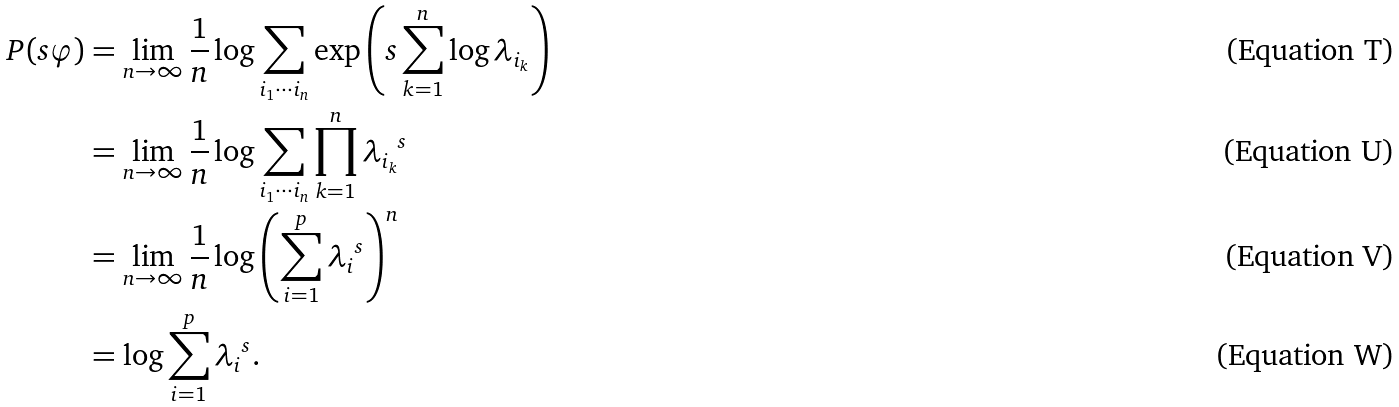<formula> <loc_0><loc_0><loc_500><loc_500>P ( s \varphi ) & = \lim _ { n \to \infty } \frac { 1 } { n } \log \sum _ { i _ { 1 } \cdots i _ { n } } \exp \left ( s \sum _ { k = 1 } ^ { n } \log \lambda _ { i _ { k } } \right ) \\ & = \lim _ { n \to \infty } \frac { 1 } { n } \log \sum _ { i _ { 1 } \cdots i _ { n } } \prod _ { k = 1 } ^ { n } { \lambda _ { i _ { k } } } ^ { s } \\ & = \lim _ { n \to \infty } \frac { 1 } { n } \log \left ( \sum _ { i = 1 } ^ { p } { \lambda _ { i } } ^ { s } \right ) ^ { n } \\ & = \log \sum _ { i = 1 } ^ { p } { \lambda _ { i } } ^ { s } .</formula> 